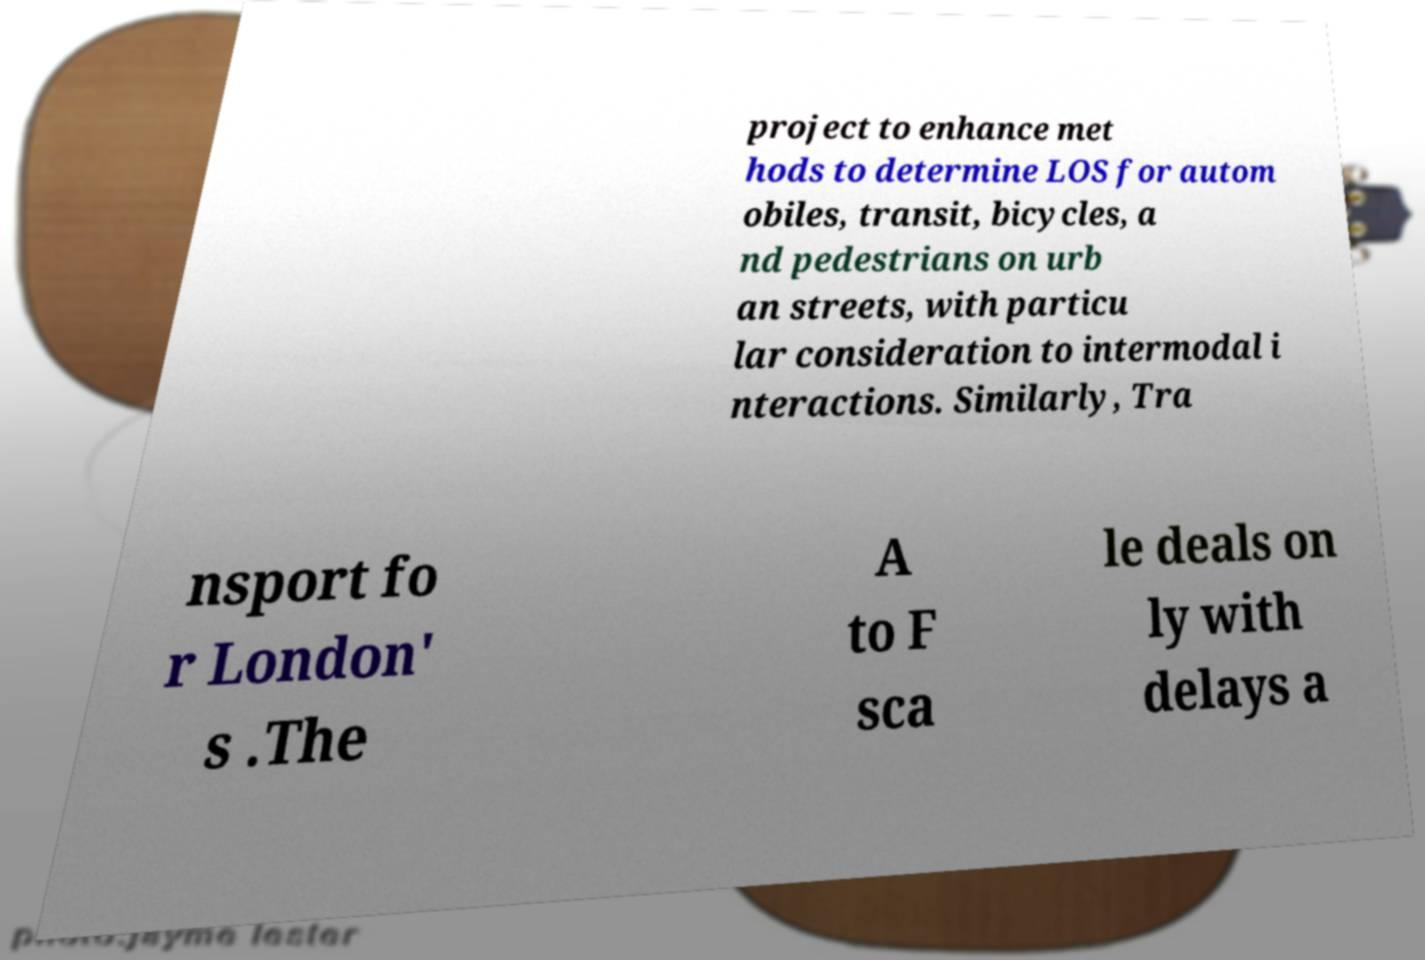Can you read and provide the text displayed in the image?This photo seems to have some interesting text. Can you extract and type it out for me? project to enhance met hods to determine LOS for autom obiles, transit, bicycles, a nd pedestrians on urb an streets, with particu lar consideration to intermodal i nteractions. Similarly, Tra nsport fo r London' s .The A to F sca le deals on ly with delays a 